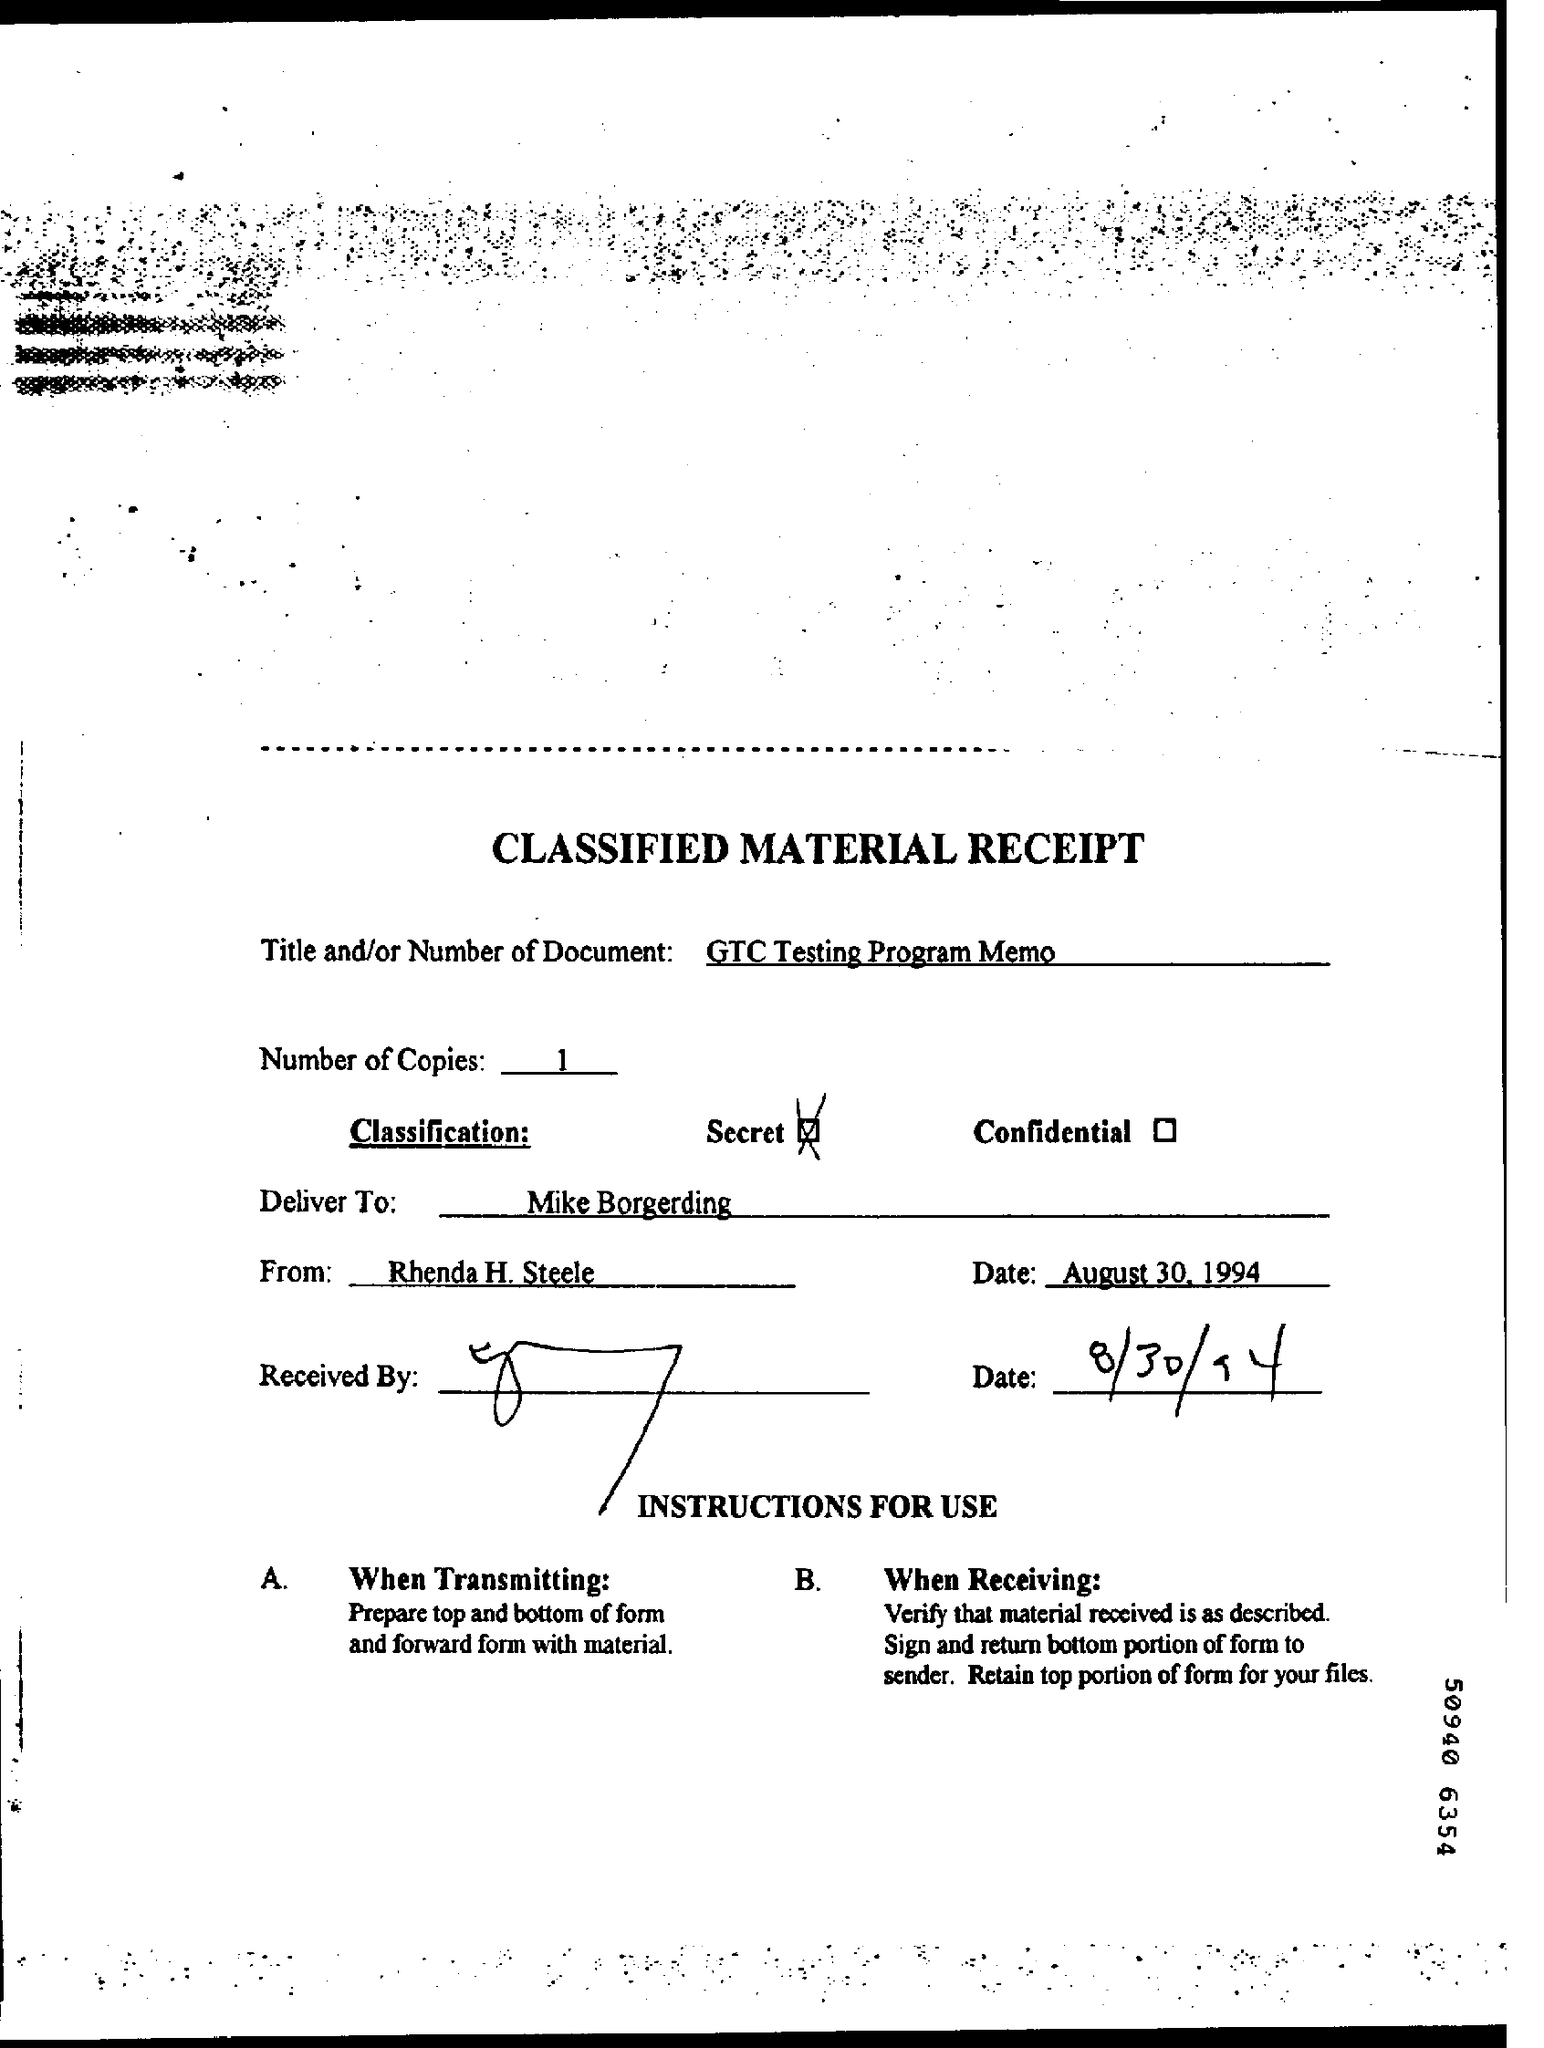What is written in the Title Field ?
Make the answer very short. GTC Testing Program Memo. How many Copies are there ?
Give a very brief answer. 1. Who is the Memorandum addressed to ?
Offer a very short reply. Mike Borgerding. Who is the Memorandum from ?
Make the answer very short. Rhenda H. Steele. What is the RECEIVED Date ?
Ensure brevity in your answer.  8/30/94. 